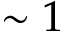<formula> <loc_0><loc_0><loc_500><loc_500>\sim 1</formula> 